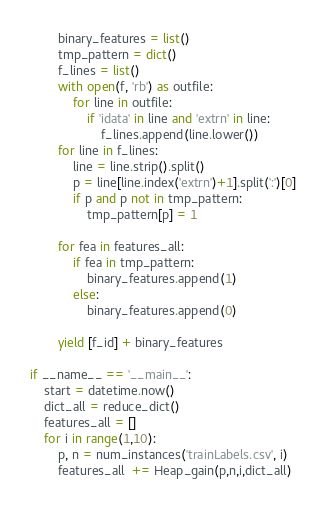<code> <loc_0><loc_0><loc_500><loc_500><_Python_>
        binary_features = list()
        tmp_pattern = dict()
        f_lines = list()
        with open(f, 'rb') as outfile:
            for line in outfile:
                if 'idata' in line and 'extrn' in line:
                    f_lines.append(line.lower())
        for line in f_lines:
            line = line.strip().split()
            p = line[line.index('extrn')+1].split(':')[0]
            if p and p not in tmp_pattern:
                tmp_pattern[p] = 1

        for fea in features_all:
            if fea in tmp_pattern:
                binary_features.append(1)
            else:
                binary_features.append(0)

        yield [f_id] + binary_features

if __name__ == '__main__':
    start = datetime.now()
    dict_all = reduce_dict()
    features_all = []
    for i in range(1,10):
        p, n = num_instances('trainLabels.csv', i)
        features_all  += Heap_gain(p,n,i,dict_all)</code> 